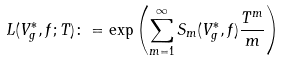<formula> <loc_0><loc_0><loc_500><loc_500>L ( V _ { g } ^ { * } , f ; T ) \colon = \exp \left ( \sum _ { m = 1 } ^ { \infty } S _ { m } ( V _ { g } ^ { * } , f ) \frac { T ^ { m } } { m } \right )</formula> 